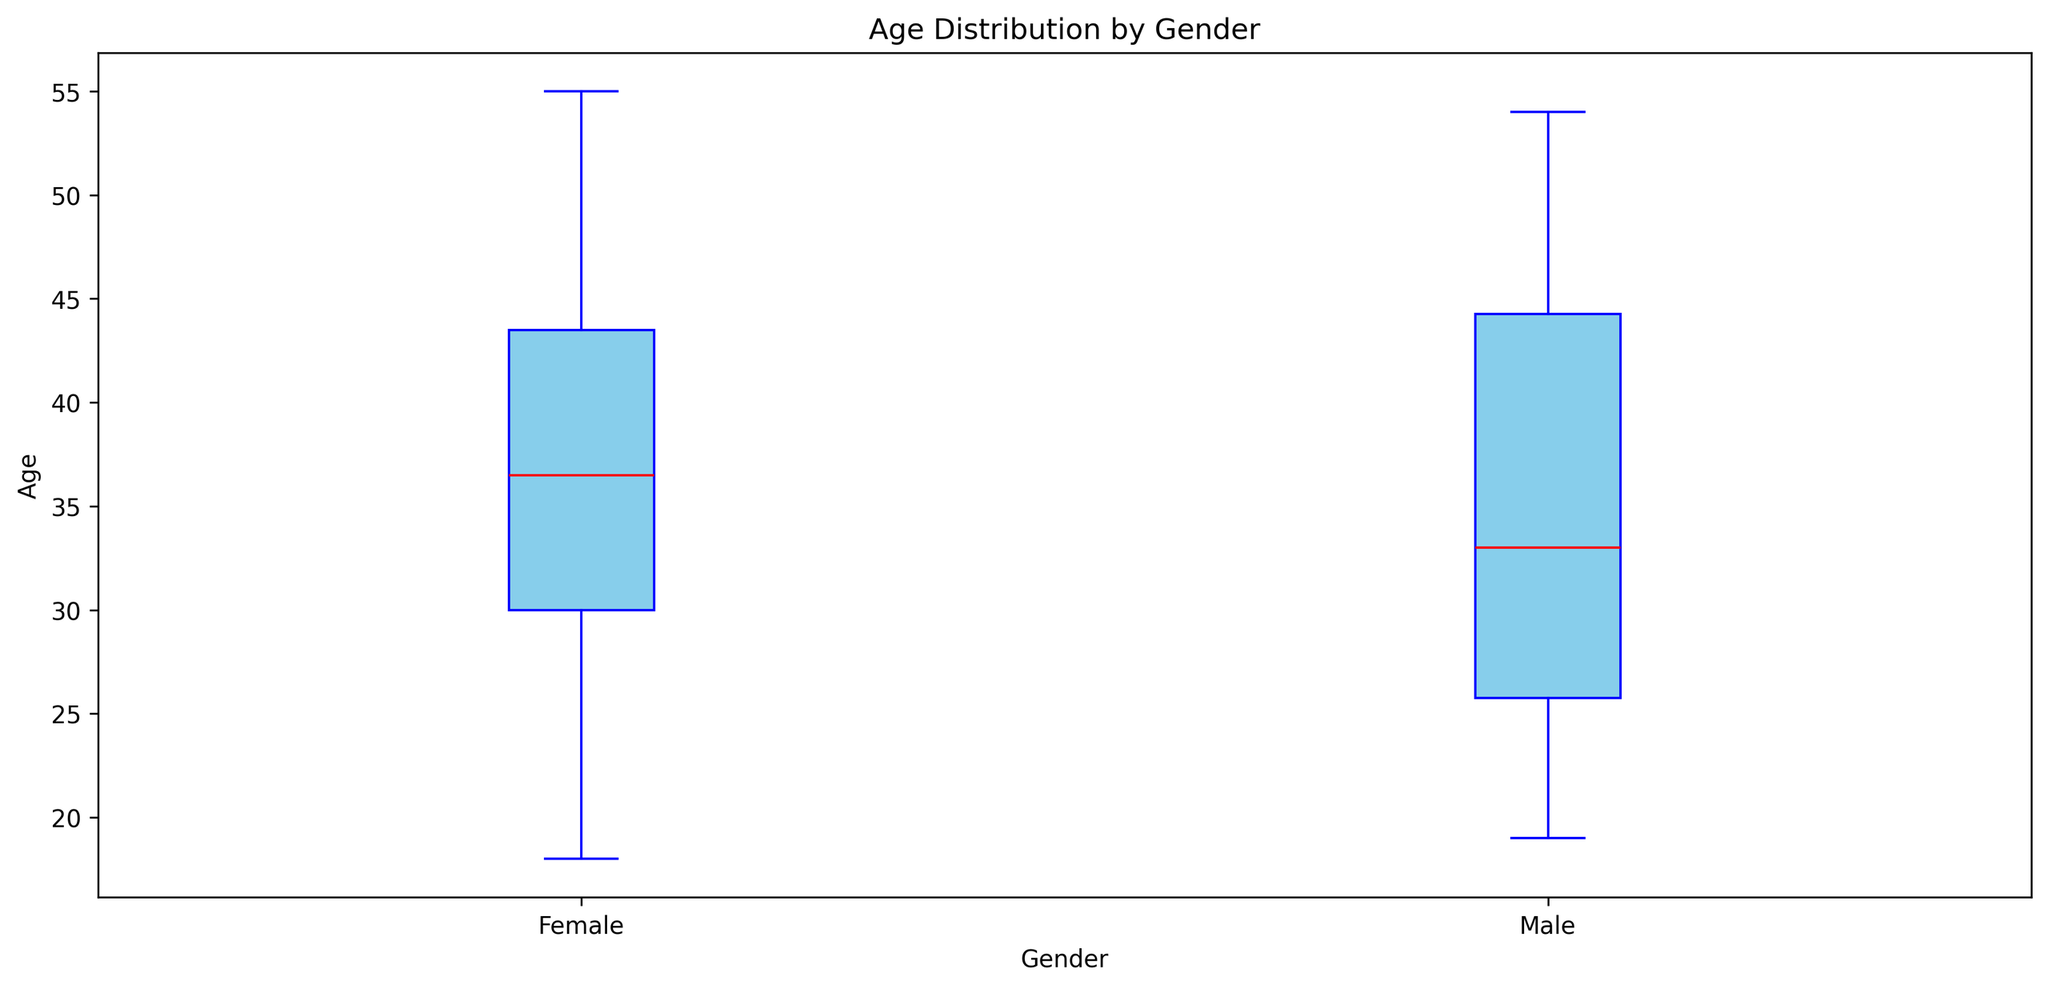Which gender has the highest median age? The boxplot shows the median age as a red line within each box. Compare the positions of the red lines for Male and Female categories.
Answer: Male What is the median age for females? Identify the red line within the Female category box on the boxplot.
Answer: 38 How does the range of ages for males compare to that of females? Observe the spread of the whiskers (vertical lines extending from each box) from the minimum to the maximum age in both Male and Female categories.
Answer: Male has a greater range Which gender has the widest interquartile range (IQR)? Compare the height of the boxes (representing the IQR) for Male and Female categories.
Answer: Male What is the age range of males depicted in the boxplot? Identify the minimum and maximum points of the whiskers (vertical lines) for the Male category.
Answer: 18 to 55 Which gender has more outliers, and how can you tell? Look for individual points plotted outside the whiskers for each gender. Count them to determine which has more outliers.
Answer: Female, 2 outliers Is the median age for males greater than for females? Compare the positions of the red lines within the Male and Female boxes.
Answer: Yes What does the height of each box represent in the boxplot? The height of the box represents the interquartile range (IQR), which is the middle 50% of the data.
Answer: Interquartile Range For which gender does the difference between the 1st quartile and the median appear larger? Compare the vertical distance between the bottom of the box and the red line (median) for both genders.
Answer: Male Which gender displays a larger variability in age distribution? Look for the gender with the larger overall range, considering both the IQR and the whiskers' length.
Answer: Male 